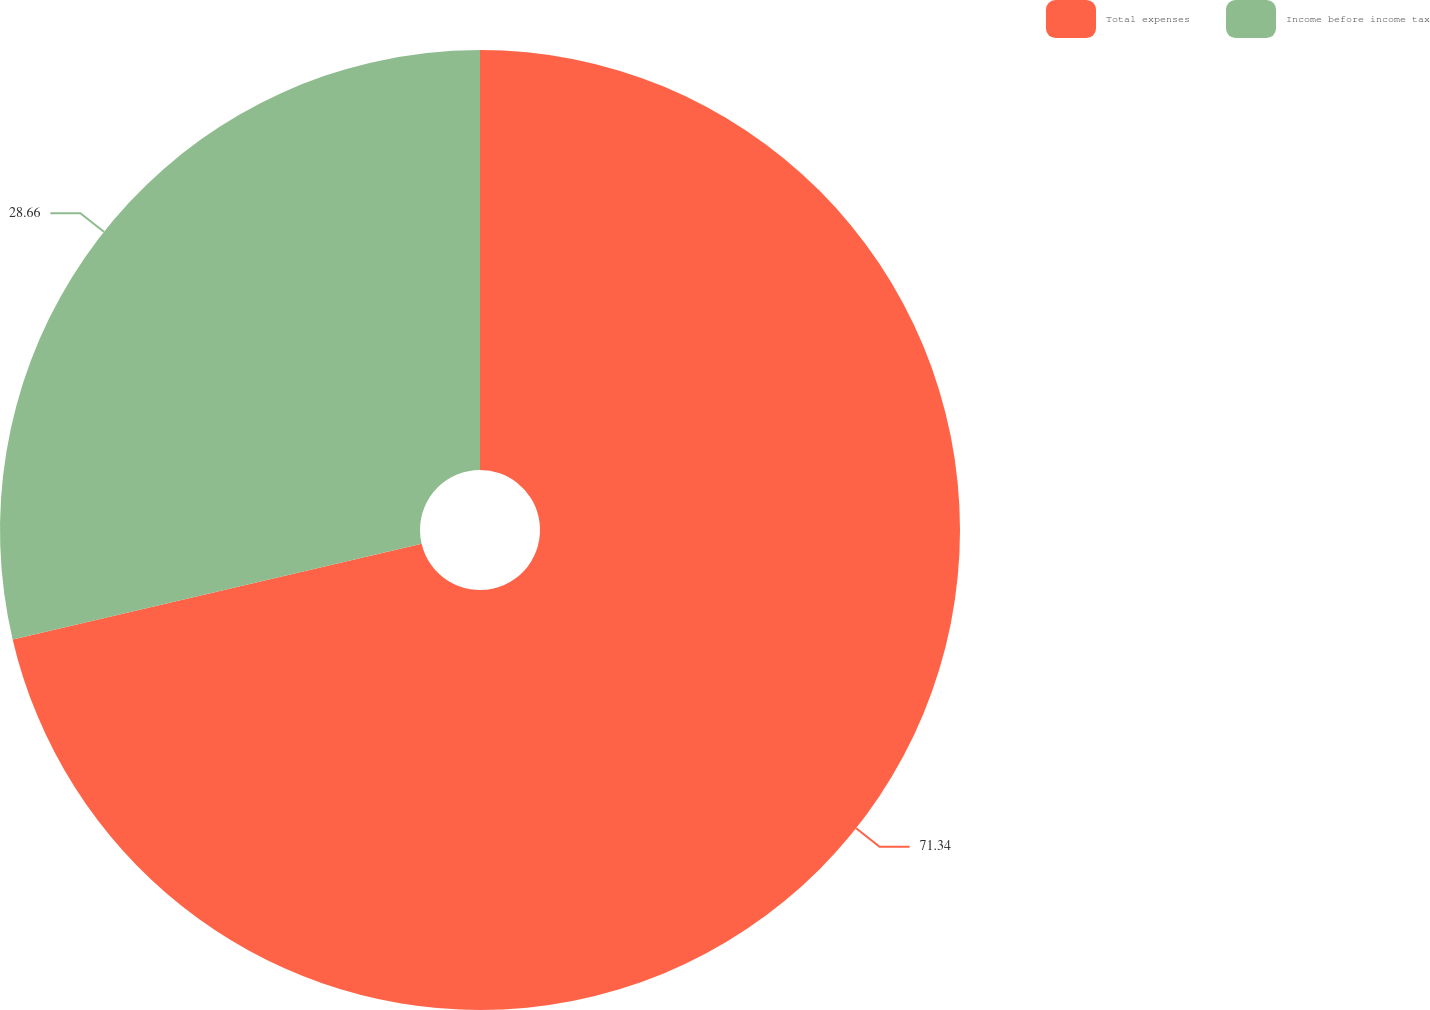Convert chart to OTSL. <chart><loc_0><loc_0><loc_500><loc_500><pie_chart><fcel>Total expenses<fcel>Income before income tax<nl><fcel>71.34%<fcel>28.66%<nl></chart> 